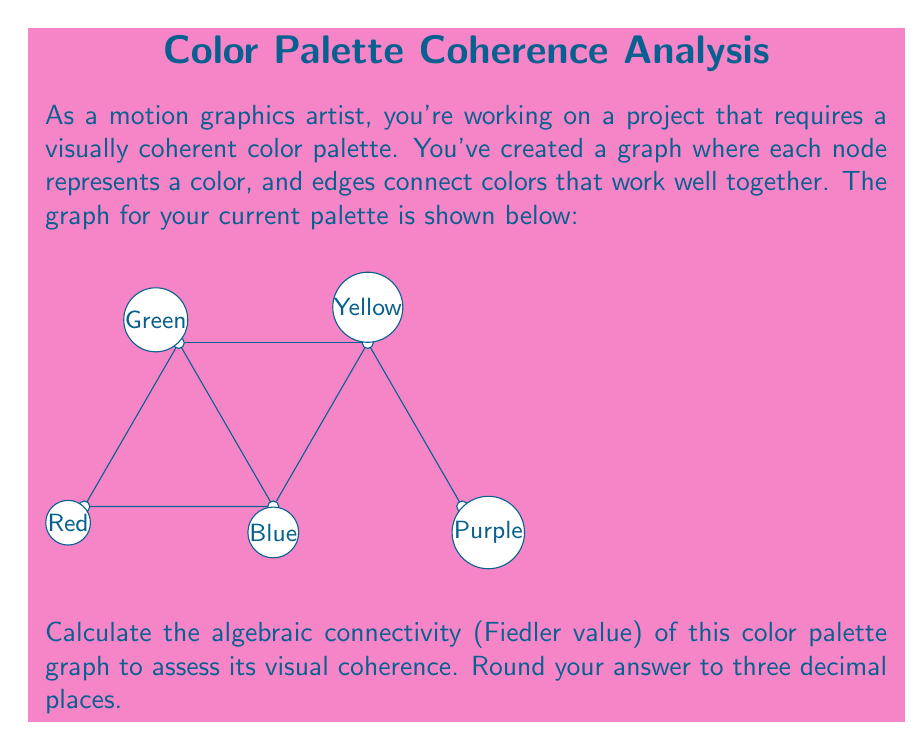Can you solve this math problem? To find the algebraic connectivity (Fiedler value) of the graph, we need to follow these steps:

1) First, construct the adjacency matrix $A$ of the graph:

   $$A = \begin{bmatrix}
   0 & 1 & 1 & 0 & 0 \\
   1 & 0 & 1 & 1 & 0 \\
   1 & 1 & 0 & 1 & 0 \\
   0 & 1 & 1 & 0 & 1 \\
   0 & 0 & 0 & 1 & 0
   \end{bmatrix}$$

2) Calculate the degree matrix $D$:

   $$D = \begin{bmatrix}
   2 & 0 & 0 & 0 & 0 \\
   0 & 3 & 0 & 0 & 0 \\
   0 & 0 & 3 & 0 & 0 \\
   0 & 0 & 0 & 3 & 0 \\
   0 & 0 & 0 & 0 & 1
   \end{bmatrix}$$

3) Compute the Laplacian matrix $L = D - A$:

   $$L = \begin{bmatrix}
   2 & -1 & -1 & 0 & 0 \\
   -1 & 3 & -1 & -1 & 0 \\
   -1 & -1 & 3 & -1 & 0 \\
   0 & -1 & -1 & 3 & -1 \\
   0 & 0 & 0 & -1 & 1
   \end{bmatrix}$$

4) Find the eigenvalues of $L$. Using a computer algebra system, we get:

   $\lambda_1 = 0$
   $\lambda_2 \approx 0.5188$
   $\lambda_3 \approx 2.0000$
   $\lambda_4 \approx 3.3473$
   $\lambda_5 \approx 4.1339$

5) The algebraic connectivity (Fiedler value) is the second smallest eigenvalue, which is $\lambda_2 \approx 0.5188$.

6) Rounding to three decimal places, we get 0.519.

The Fiedler value provides a measure of how well-connected the graph is. A higher value indicates better connectivity and, in this context, better visual coherence of the color palette.
Answer: 0.519 